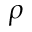<formula> <loc_0><loc_0><loc_500><loc_500>\rho</formula> 